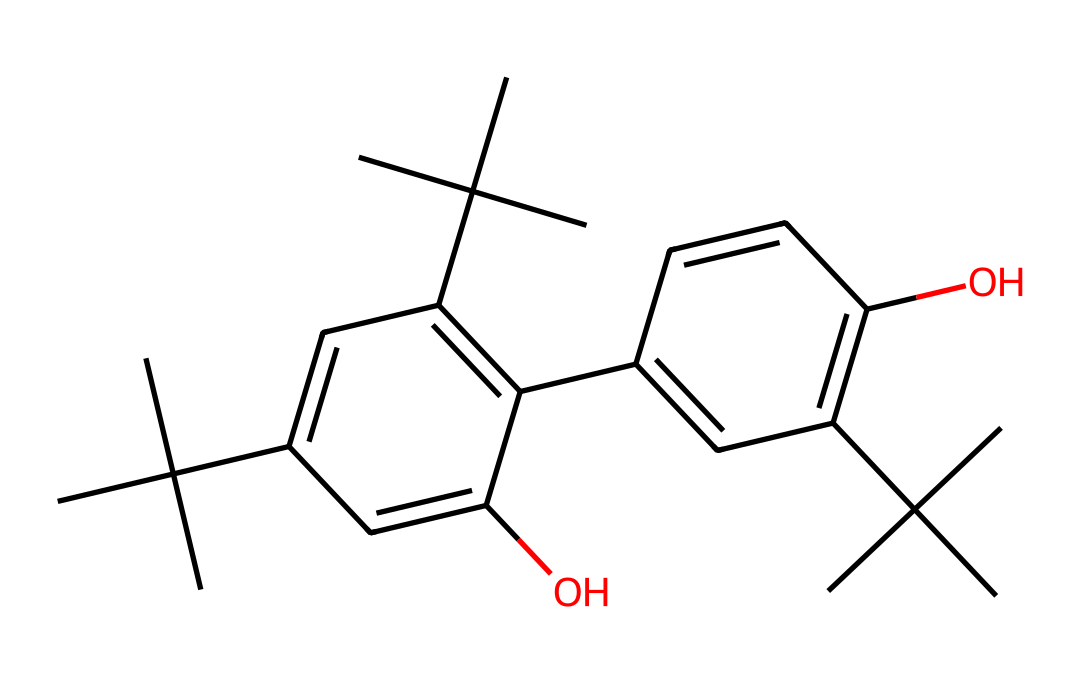What is the molecular formula of this compound? To determine the molecular formula, count the number of each type of atom in the SMILES representation. In this case, there are 27 carbon atoms, 34 hydrogen atoms, and 4 oxygen atoms, leading to the formula C27H34O4.
Answer: C27H34O4 How many hydroxyl (−OH) groups are present? The structure contains two hydroxyl groups since there are two 'O' atoms in the structure associated with visible carbon bonds indicative of alcohol functionality.
Answer: 2 What is the primary functional group observed in this compound? The presence of the hydroxyl (−OH) groups indicates that the primary functional group is phenol due to the aromatic ring's attachment to hydroxyl groups.
Answer: phenol How many aromatic rings are present in the structure? By examining the SMILES representation, visually identifiable segments indicate that there are two distinct aromatic rings due to the presence of conjugated double bonds (C=C) in each cyclic structure.
Answer: 2 Is this compound a polymer? The compound has a defined structure without repeating units characteristic of polymers, suggesting it is a small molecule or oligomer rather than a polymer.
Answer: No What type of chemical environment is indicated by the presence of multiple tertiary carbon centers? The numerous branching points denote a highly substituted environment typical of tertiary carbons, influencing the chemical's reactivity and stability while also highlighting its complexity.
Answer: tertiary Is this compound likely to be hydrophilic or hydrophobic? The presence of hydroxyl groups suggests it has polar characteristics, making it capable of interacting with water molecules, thus indicating it is hydrophilic.
Answer: hydrophilic 